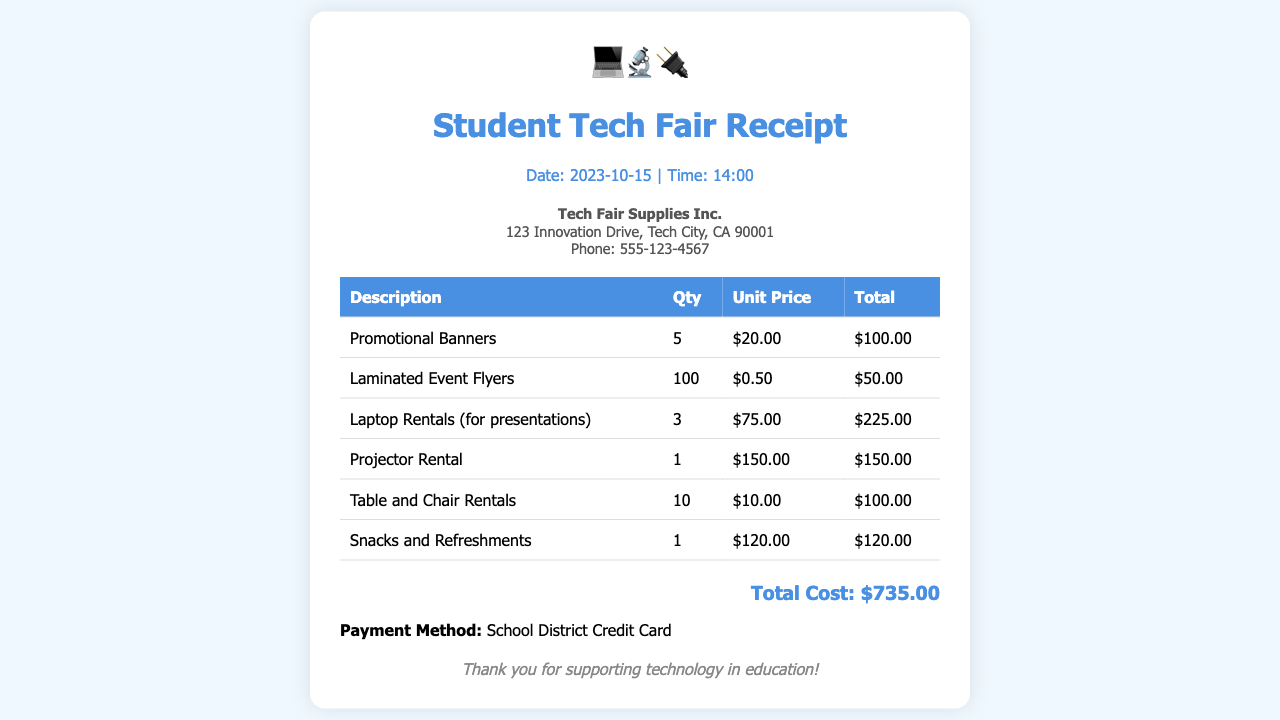what is the total cost? The total cost is clearly stated at the bottom of the receipt.
Answer: $735.00 what date was the receipt issued? The date is mentioned in the header section of the receipt.
Answer: 2023-10-15 who is the vendor? The vendor's name is listed in the vendor details section.
Answer: Tech Fair Supplies Inc how many promotional banners were purchased? The quantity of promotional banners is listed in the table under the description "Promotional Banners."
Answer: 5 what is the unit price of laptop rentals? The unit price can be found in the table under "Laptop Rentals (for presentations)."
Answer: $75.00 what is the total for snacks and refreshments? The total for snacks and refreshments is specified in the table under that item.
Answer: $120.00 how many laminated event flyers were ordered? The quantity ordered is mentioned in the description of laminated event flyers in the table.
Answer: 100 what payment method was used? The payment method is stated near the total cost in the receipt.
Answer: School District Credit Card what is the price of the projector rental? The price of the projector rental can be found in the rentals section.
Answer: $150.00 